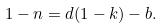<formula> <loc_0><loc_0><loc_500><loc_500>1 - n = d ( 1 - k ) - b .</formula> 